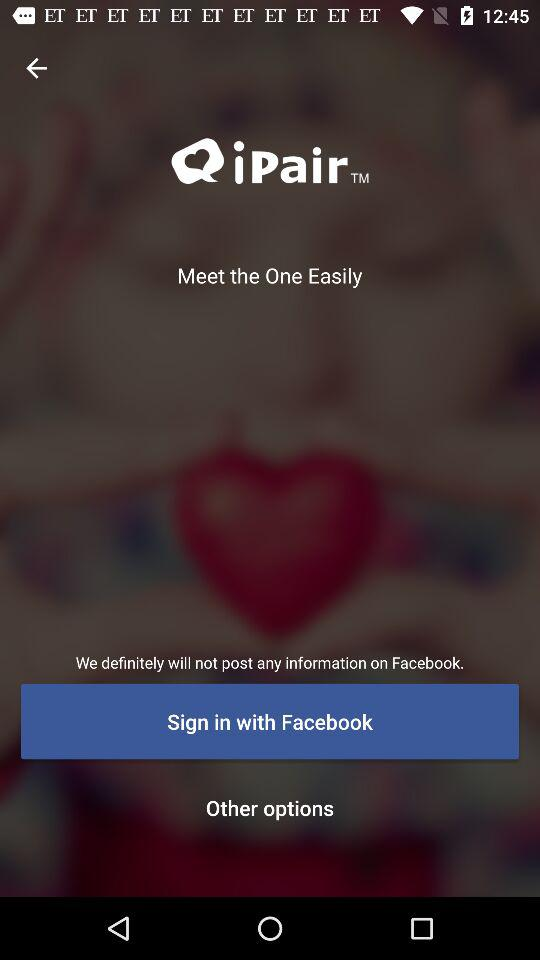What is the name of the application? The name of the application is "iPair". 